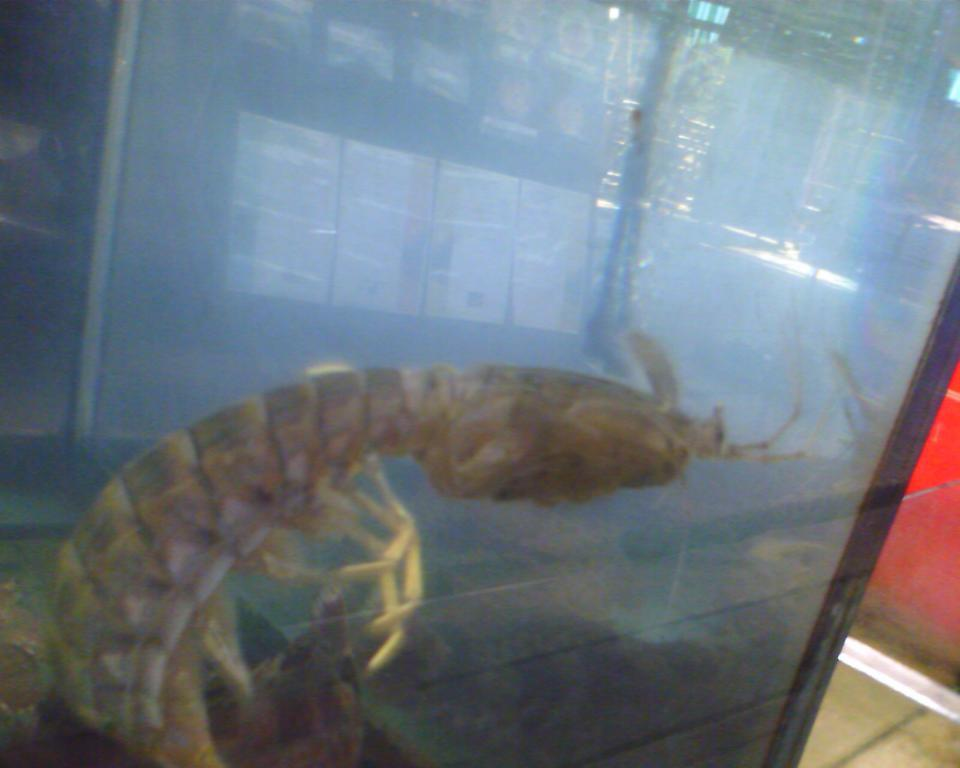What type of animal can be seen in the image? There is an aquatic animal in the image. What color is the aquatic animal? The animal is in brown color. What type of destruction is the aquatic animal causing in the image? There is no destruction present in the image; it simply features an aquatic animal in brown color. 